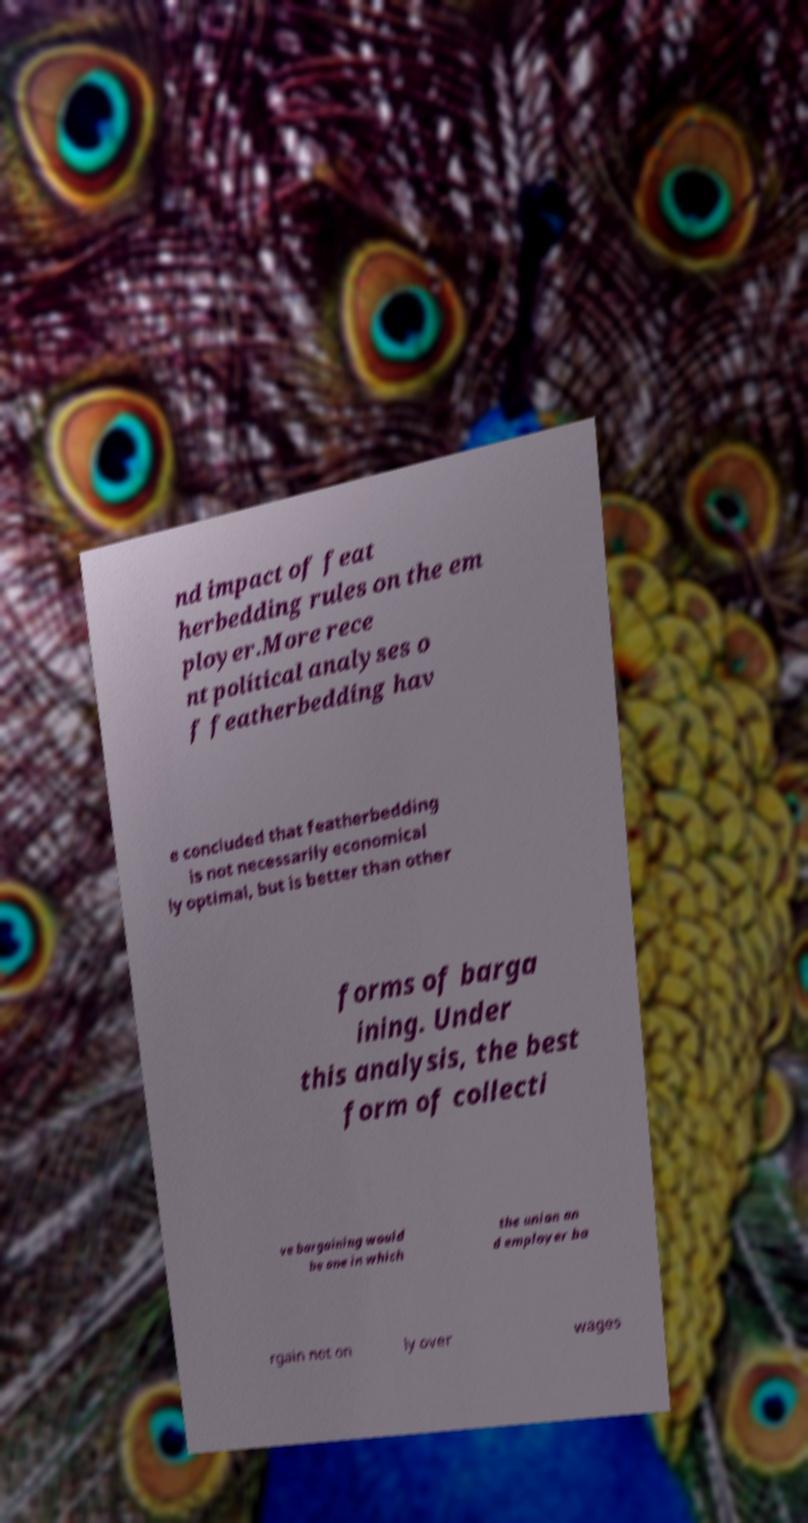What messages or text are displayed in this image? I need them in a readable, typed format. nd impact of feat herbedding rules on the em ployer.More rece nt political analyses o f featherbedding hav e concluded that featherbedding is not necessarily economical ly optimal, but is better than other forms of barga ining. Under this analysis, the best form of collecti ve bargaining would be one in which the union an d employer ba rgain not on ly over wages 